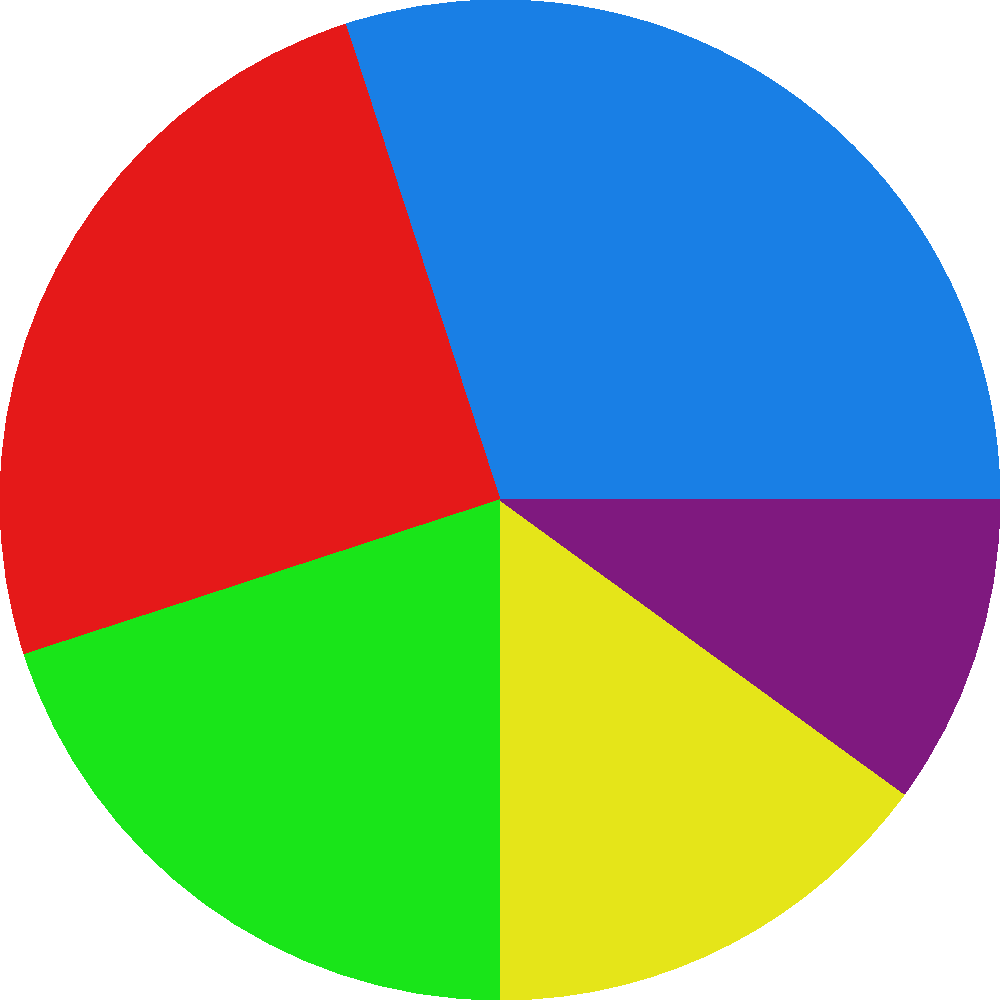As a new online boutique owner, you're considering various investment options for business growth. The pie chart shows the allocation of a $100,000 investment across different areas. If you decide to increase your investment in the E-commerce Platform by 5% of the total investment, how much additional money (in dollars) would you need to allocate to this area? To solve this problem, let's follow these steps:

1. Identify the current allocation for the E-commerce Platform:
   From the pie chart, we can see that E-commerce Platform currently has 20% of the total investment.

2. Calculate the current dollar amount for E-commerce Platform:
   Total investment = $100,000
   Current E-commerce Platform allocation = 20% of $100,000
   $100,000 × 20% = $20,000

3. Calculate the new allocation percentage for E-commerce Platform:
   Current percentage = 20%
   Increase = 5%
   New percentage = 20% + 5% = 25%

4. Calculate the new dollar amount for E-commerce Platform:
   New allocation = 25% of $100,000
   $100,000 × 25% = $25,000

5. Calculate the difference between the new and current allocations:
   Additional investment = New allocation - Current allocation
   $25,000 - $20,000 = $5,000

Therefore, you would need to allocate an additional $5,000 to the E-commerce Platform to increase its share by 5% of the total investment.
Answer: $5,000 